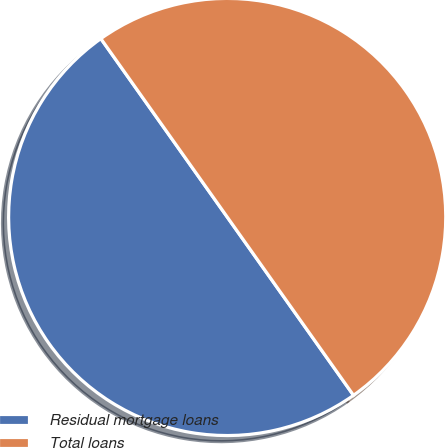Convert chart to OTSL. <chart><loc_0><loc_0><loc_500><loc_500><pie_chart><fcel>Residual mortgage loans<fcel>Total loans<nl><fcel>50.0%<fcel>50.0%<nl></chart> 